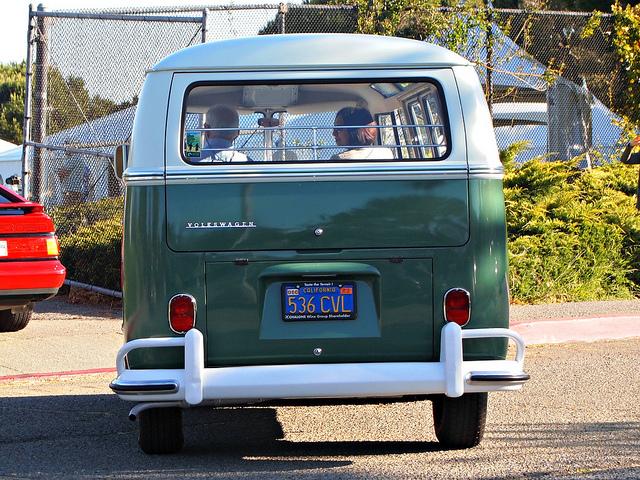What kind of vehicle is this?
Short answer required. Van. How many people in the van?
Give a very brief answer. 2. What color is the van?
Be succinct. Green and white. 